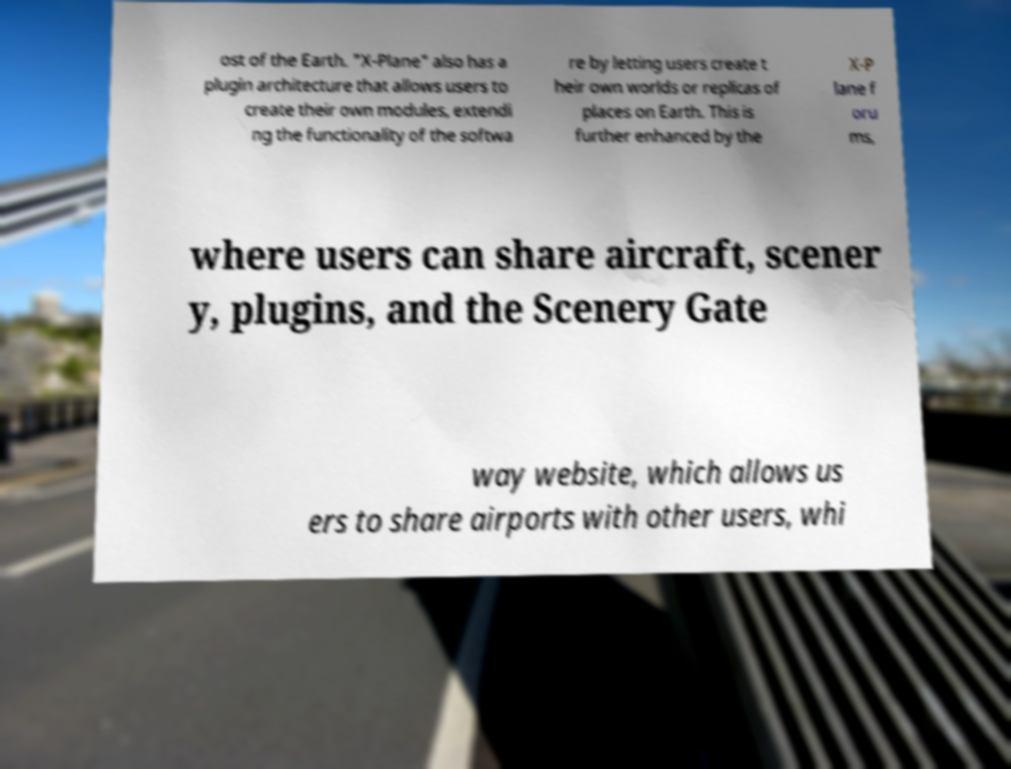Can you read and provide the text displayed in the image?This photo seems to have some interesting text. Can you extract and type it out for me? ost of the Earth. "X-Plane" also has a plugin architecture that allows users to create their own modules, extendi ng the functionality of the softwa re by letting users create t heir own worlds or replicas of places on Earth. This is further enhanced by the X-P lane f oru ms, where users can share aircraft, scener y, plugins, and the Scenery Gate way website, which allows us ers to share airports with other users, whi 